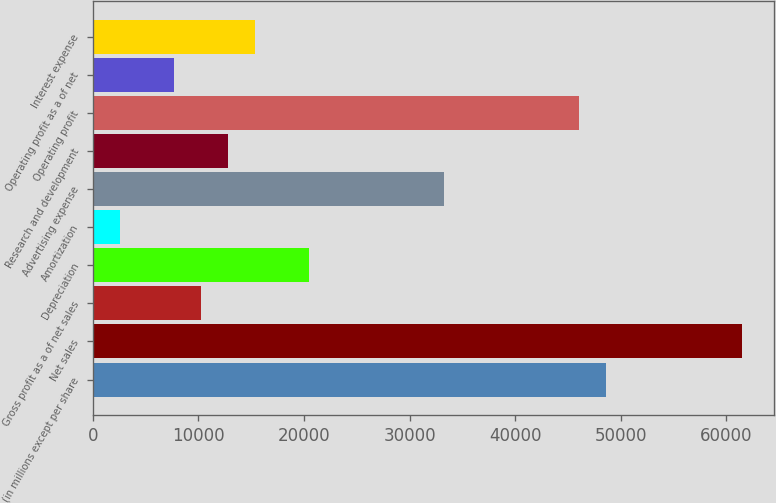Convert chart. <chart><loc_0><loc_0><loc_500><loc_500><bar_chart><fcel>(in millions except per share<fcel>Net sales<fcel>Gross profit as a of net sales<fcel>Depreciation<fcel>Amortization<fcel>Advertising expense<fcel>Research and development<fcel>Operating profit<fcel>Operating profit as a of net<fcel>Interest expense<nl><fcel>48650.4<fcel>61452.8<fcel>10243<fcel>20485<fcel>2561.55<fcel>33287.4<fcel>12803.5<fcel>46089.9<fcel>7682.53<fcel>15364<nl></chart> 